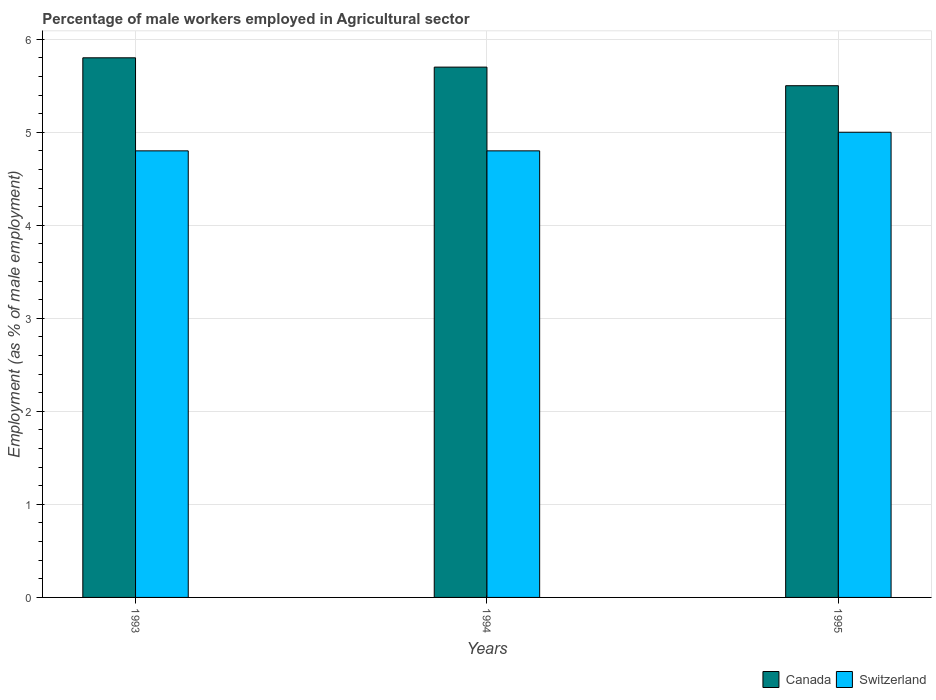How many different coloured bars are there?
Ensure brevity in your answer.  2. How many groups of bars are there?
Provide a short and direct response. 3. Are the number of bars per tick equal to the number of legend labels?
Provide a short and direct response. Yes. Are the number of bars on each tick of the X-axis equal?
Offer a very short reply. Yes. How many bars are there on the 3rd tick from the left?
Provide a short and direct response. 2. What is the label of the 3rd group of bars from the left?
Make the answer very short. 1995. In which year was the percentage of male workers employed in Agricultural sector in Switzerland minimum?
Keep it short and to the point. 1993. What is the total percentage of male workers employed in Agricultural sector in Switzerland in the graph?
Your response must be concise. 14.6. What is the difference between the percentage of male workers employed in Agricultural sector in Canada in 1994 and that in 1995?
Keep it short and to the point. 0.2. What is the difference between the percentage of male workers employed in Agricultural sector in Canada in 1993 and the percentage of male workers employed in Agricultural sector in Switzerland in 1995?
Offer a terse response. 0.8. What is the average percentage of male workers employed in Agricultural sector in Canada per year?
Your response must be concise. 5.67. In the year 1995, what is the difference between the percentage of male workers employed in Agricultural sector in Switzerland and percentage of male workers employed in Agricultural sector in Canada?
Offer a very short reply. -0.5. In how many years, is the percentage of male workers employed in Agricultural sector in Switzerland greater than 5.2 %?
Keep it short and to the point. 0. What is the ratio of the percentage of male workers employed in Agricultural sector in Canada in 1993 to that in 1995?
Make the answer very short. 1.05. Is the percentage of male workers employed in Agricultural sector in Switzerland in 1993 less than that in 1994?
Your answer should be very brief. No. Is the difference between the percentage of male workers employed in Agricultural sector in Switzerland in 1993 and 1995 greater than the difference between the percentage of male workers employed in Agricultural sector in Canada in 1993 and 1995?
Provide a succinct answer. No. What is the difference between the highest and the second highest percentage of male workers employed in Agricultural sector in Canada?
Give a very brief answer. 0.1. What is the difference between the highest and the lowest percentage of male workers employed in Agricultural sector in Switzerland?
Offer a terse response. 0.2. In how many years, is the percentage of male workers employed in Agricultural sector in Switzerland greater than the average percentage of male workers employed in Agricultural sector in Switzerland taken over all years?
Offer a very short reply. 1. Is the sum of the percentage of male workers employed in Agricultural sector in Canada in 1993 and 1994 greater than the maximum percentage of male workers employed in Agricultural sector in Switzerland across all years?
Offer a terse response. Yes. What does the 2nd bar from the left in 1995 represents?
Your response must be concise. Switzerland. How many bars are there?
Make the answer very short. 6. Are all the bars in the graph horizontal?
Your answer should be compact. No. What is the difference between two consecutive major ticks on the Y-axis?
Your answer should be compact. 1. Does the graph contain any zero values?
Provide a succinct answer. No. Does the graph contain grids?
Ensure brevity in your answer.  Yes. Where does the legend appear in the graph?
Offer a terse response. Bottom right. How are the legend labels stacked?
Ensure brevity in your answer.  Horizontal. What is the title of the graph?
Ensure brevity in your answer.  Percentage of male workers employed in Agricultural sector. Does "Morocco" appear as one of the legend labels in the graph?
Give a very brief answer. No. What is the label or title of the X-axis?
Offer a very short reply. Years. What is the label or title of the Y-axis?
Provide a short and direct response. Employment (as % of male employment). What is the Employment (as % of male employment) of Canada in 1993?
Ensure brevity in your answer.  5.8. What is the Employment (as % of male employment) in Switzerland in 1993?
Ensure brevity in your answer.  4.8. What is the Employment (as % of male employment) in Canada in 1994?
Give a very brief answer. 5.7. What is the Employment (as % of male employment) in Switzerland in 1994?
Keep it short and to the point. 4.8. What is the Employment (as % of male employment) in Canada in 1995?
Your answer should be compact. 5.5. What is the Employment (as % of male employment) of Switzerland in 1995?
Offer a terse response. 5. Across all years, what is the maximum Employment (as % of male employment) of Canada?
Provide a succinct answer. 5.8. Across all years, what is the maximum Employment (as % of male employment) of Switzerland?
Offer a very short reply. 5. Across all years, what is the minimum Employment (as % of male employment) of Canada?
Provide a succinct answer. 5.5. Across all years, what is the minimum Employment (as % of male employment) in Switzerland?
Offer a very short reply. 4.8. What is the difference between the Employment (as % of male employment) of Canada in 1993 and that in 1994?
Provide a short and direct response. 0.1. What is the difference between the Employment (as % of male employment) of Switzerland in 1993 and that in 1994?
Ensure brevity in your answer.  0. What is the difference between the Employment (as % of male employment) in Canada in 1993 and that in 1995?
Your response must be concise. 0.3. What is the difference between the Employment (as % of male employment) in Switzerland in 1993 and that in 1995?
Provide a succinct answer. -0.2. What is the difference between the Employment (as % of male employment) of Switzerland in 1994 and that in 1995?
Your answer should be very brief. -0.2. What is the difference between the Employment (as % of male employment) in Canada in 1993 and the Employment (as % of male employment) in Switzerland in 1994?
Provide a short and direct response. 1. What is the difference between the Employment (as % of male employment) of Canada in 1993 and the Employment (as % of male employment) of Switzerland in 1995?
Offer a very short reply. 0.8. What is the difference between the Employment (as % of male employment) in Canada in 1994 and the Employment (as % of male employment) in Switzerland in 1995?
Offer a terse response. 0.7. What is the average Employment (as % of male employment) in Canada per year?
Provide a succinct answer. 5.67. What is the average Employment (as % of male employment) in Switzerland per year?
Ensure brevity in your answer.  4.87. In the year 1994, what is the difference between the Employment (as % of male employment) in Canada and Employment (as % of male employment) in Switzerland?
Keep it short and to the point. 0.9. In the year 1995, what is the difference between the Employment (as % of male employment) of Canada and Employment (as % of male employment) of Switzerland?
Provide a succinct answer. 0.5. What is the ratio of the Employment (as % of male employment) of Canada in 1993 to that in 1994?
Provide a succinct answer. 1.02. What is the ratio of the Employment (as % of male employment) of Switzerland in 1993 to that in 1994?
Keep it short and to the point. 1. What is the ratio of the Employment (as % of male employment) in Canada in 1993 to that in 1995?
Provide a succinct answer. 1.05. What is the ratio of the Employment (as % of male employment) of Canada in 1994 to that in 1995?
Provide a succinct answer. 1.04. What is the ratio of the Employment (as % of male employment) of Switzerland in 1994 to that in 1995?
Give a very brief answer. 0.96. What is the difference between the highest and the second highest Employment (as % of male employment) in Canada?
Offer a very short reply. 0.1. What is the difference between the highest and the second highest Employment (as % of male employment) in Switzerland?
Your response must be concise. 0.2. 